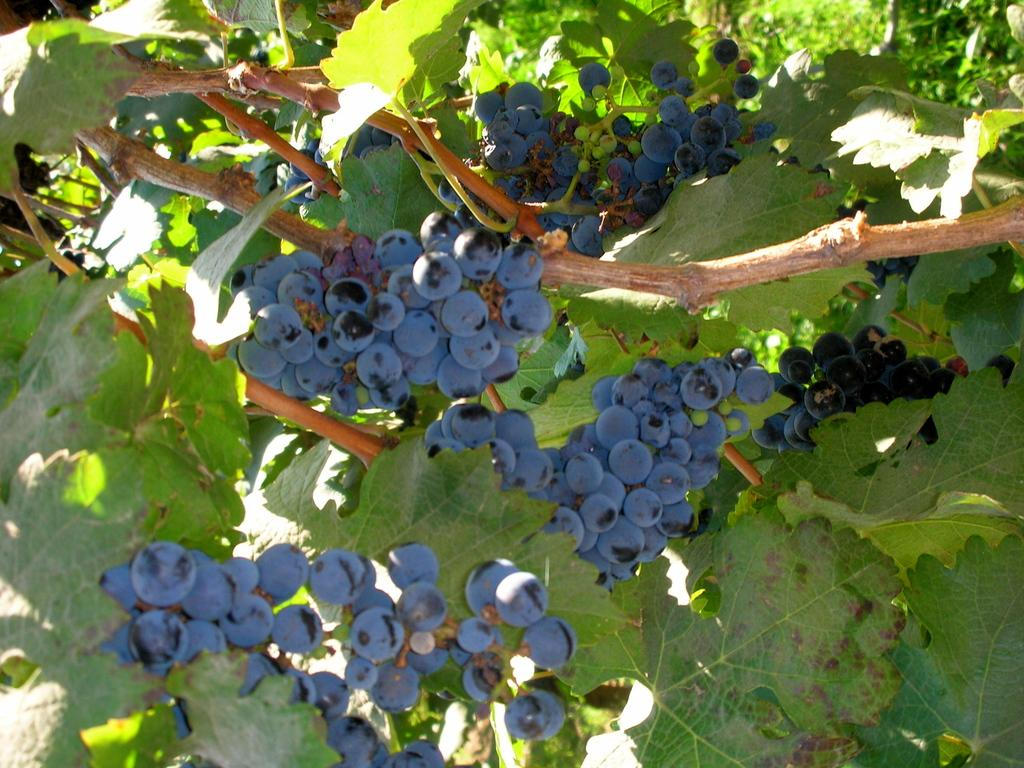What type of plant can be seen in the image? There is a tree in the image. What is growing on the tree? There are grapes on the tree. What is the cause of the grapes growing on the tree in the image? The cause of the grapes growing on the tree cannot be determined from the image alone. What type of shoes are visible on the tree in the image? There are no shoes present on the tree in the image. 